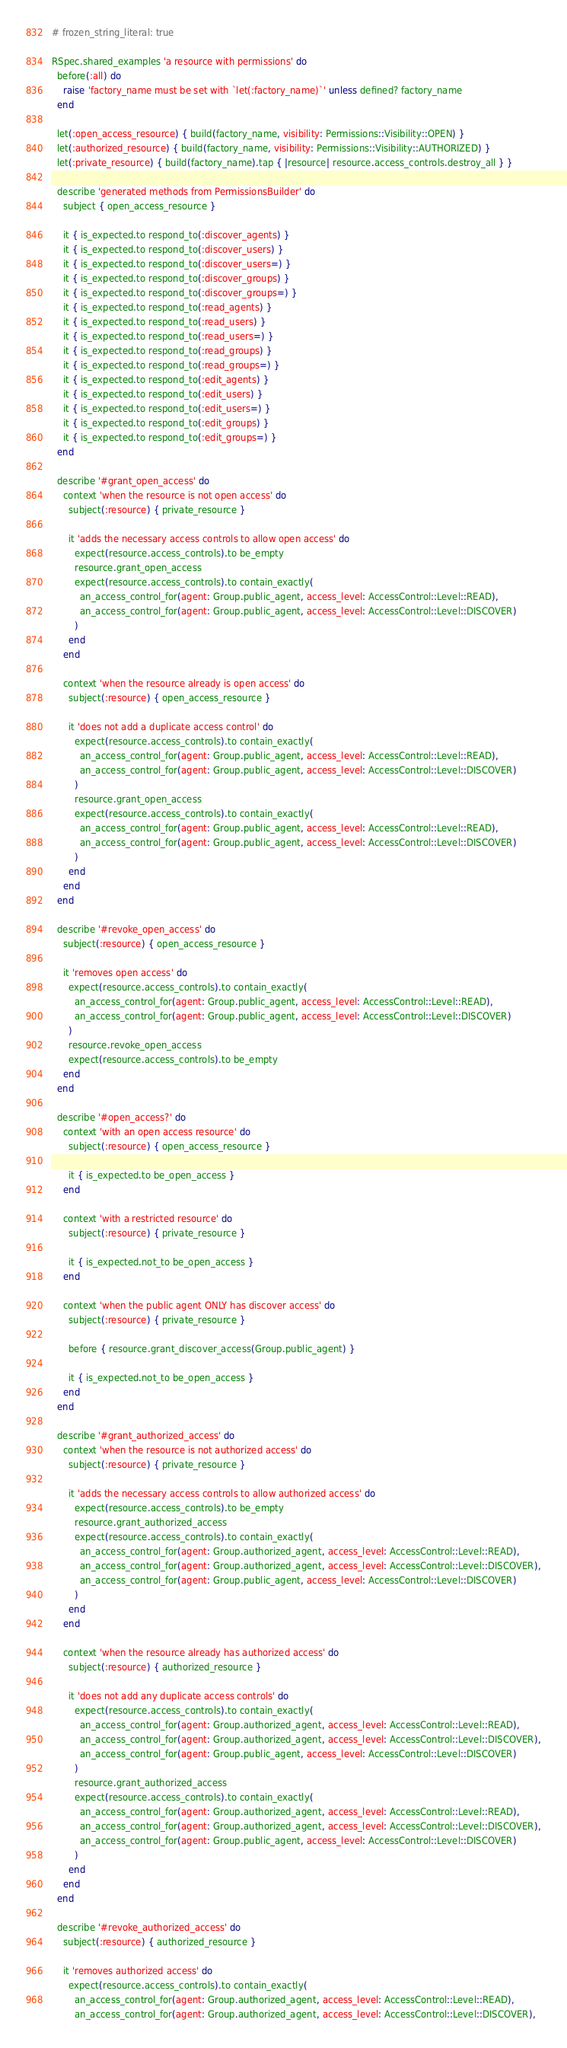Convert code to text. <code><loc_0><loc_0><loc_500><loc_500><_Ruby_># frozen_string_literal: true

RSpec.shared_examples 'a resource with permissions' do
  before(:all) do
    raise 'factory_name must be set with `let(:factory_name)`' unless defined? factory_name
  end

  let(:open_access_resource) { build(factory_name, visibility: Permissions::Visibility::OPEN) }
  let(:authorized_resource) { build(factory_name, visibility: Permissions::Visibility::AUTHORIZED) }
  let(:private_resource) { build(factory_name).tap { |resource| resource.access_controls.destroy_all } }

  describe 'generated methods from PermissionsBuilder' do
    subject { open_access_resource }

    it { is_expected.to respond_to(:discover_agents) }
    it { is_expected.to respond_to(:discover_users) }
    it { is_expected.to respond_to(:discover_users=) }
    it { is_expected.to respond_to(:discover_groups) }
    it { is_expected.to respond_to(:discover_groups=) }
    it { is_expected.to respond_to(:read_agents) }
    it { is_expected.to respond_to(:read_users) }
    it { is_expected.to respond_to(:read_users=) }
    it { is_expected.to respond_to(:read_groups) }
    it { is_expected.to respond_to(:read_groups=) }
    it { is_expected.to respond_to(:edit_agents) }
    it { is_expected.to respond_to(:edit_users) }
    it { is_expected.to respond_to(:edit_users=) }
    it { is_expected.to respond_to(:edit_groups) }
    it { is_expected.to respond_to(:edit_groups=) }
  end

  describe '#grant_open_access' do
    context 'when the resource is not open access' do
      subject(:resource) { private_resource }

      it 'adds the necessary access controls to allow open access' do
        expect(resource.access_controls).to be_empty
        resource.grant_open_access
        expect(resource.access_controls).to contain_exactly(
          an_access_control_for(agent: Group.public_agent, access_level: AccessControl::Level::READ),
          an_access_control_for(agent: Group.public_agent, access_level: AccessControl::Level::DISCOVER)
        )
      end
    end

    context 'when the resource already is open access' do
      subject(:resource) { open_access_resource }

      it 'does not add a duplicate access control' do
        expect(resource.access_controls).to contain_exactly(
          an_access_control_for(agent: Group.public_agent, access_level: AccessControl::Level::READ),
          an_access_control_for(agent: Group.public_agent, access_level: AccessControl::Level::DISCOVER)
        )
        resource.grant_open_access
        expect(resource.access_controls).to contain_exactly(
          an_access_control_for(agent: Group.public_agent, access_level: AccessControl::Level::READ),
          an_access_control_for(agent: Group.public_agent, access_level: AccessControl::Level::DISCOVER)
        )
      end
    end
  end

  describe '#revoke_open_access' do
    subject(:resource) { open_access_resource }

    it 'removes open access' do
      expect(resource.access_controls).to contain_exactly(
        an_access_control_for(agent: Group.public_agent, access_level: AccessControl::Level::READ),
        an_access_control_for(agent: Group.public_agent, access_level: AccessControl::Level::DISCOVER)
      )
      resource.revoke_open_access
      expect(resource.access_controls).to be_empty
    end
  end

  describe '#open_access?' do
    context 'with an open access resource' do
      subject(:resource) { open_access_resource }

      it { is_expected.to be_open_access }
    end

    context 'with a restricted resource' do
      subject(:resource) { private_resource }

      it { is_expected.not_to be_open_access }
    end

    context 'when the public agent ONLY has discover access' do
      subject(:resource) { private_resource }

      before { resource.grant_discover_access(Group.public_agent) }

      it { is_expected.not_to be_open_access }
    end
  end

  describe '#grant_authorized_access' do
    context 'when the resource is not authorized access' do
      subject(:resource) { private_resource }

      it 'adds the necessary access controls to allow authorized access' do
        expect(resource.access_controls).to be_empty
        resource.grant_authorized_access
        expect(resource.access_controls).to contain_exactly(
          an_access_control_for(agent: Group.authorized_agent, access_level: AccessControl::Level::READ),
          an_access_control_for(agent: Group.authorized_agent, access_level: AccessControl::Level::DISCOVER),
          an_access_control_for(agent: Group.public_agent, access_level: AccessControl::Level::DISCOVER)
        )
      end
    end

    context 'when the resource already has authorized access' do
      subject(:resource) { authorized_resource }

      it 'does not add any duplicate access controls' do
        expect(resource.access_controls).to contain_exactly(
          an_access_control_for(agent: Group.authorized_agent, access_level: AccessControl::Level::READ),
          an_access_control_for(agent: Group.authorized_agent, access_level: AccessControl::Level::DISCOVER),
          an_access_control_for(agent: Group.public_agent, access_level: AccessControl::Level::DISCOVER)
        )
        resource.grant_authorized_access
        expect(resource.access_controls).to contain_exactly(
          an_access_control_for(agent: Group.authorized_agent, access_level: AccessControl::Level::READ),
          an_access_control_for(agent: Group.authorized_agent, access_level: AccessControl::Level::DISCOVER),
          an_access_control_for(agent: Group.public_agent, access_level: AccessControl::Level::DISCOVER)
        )
      end
    end
  end

  describe '#revoke_authorized_access' do
    subject(:resource) { authorized_resource }

    it 'removes authorized access' do
      expect(resource.access_controls).to contain_exactly(
        an_access_control_for(agent: Group.authorized_agent, access_level: AccessControl::Level::READ),
        an_access_control_for(agent: Group.authorized_agent, access_level: AccessControl::Level::DISCOVER),</code> 